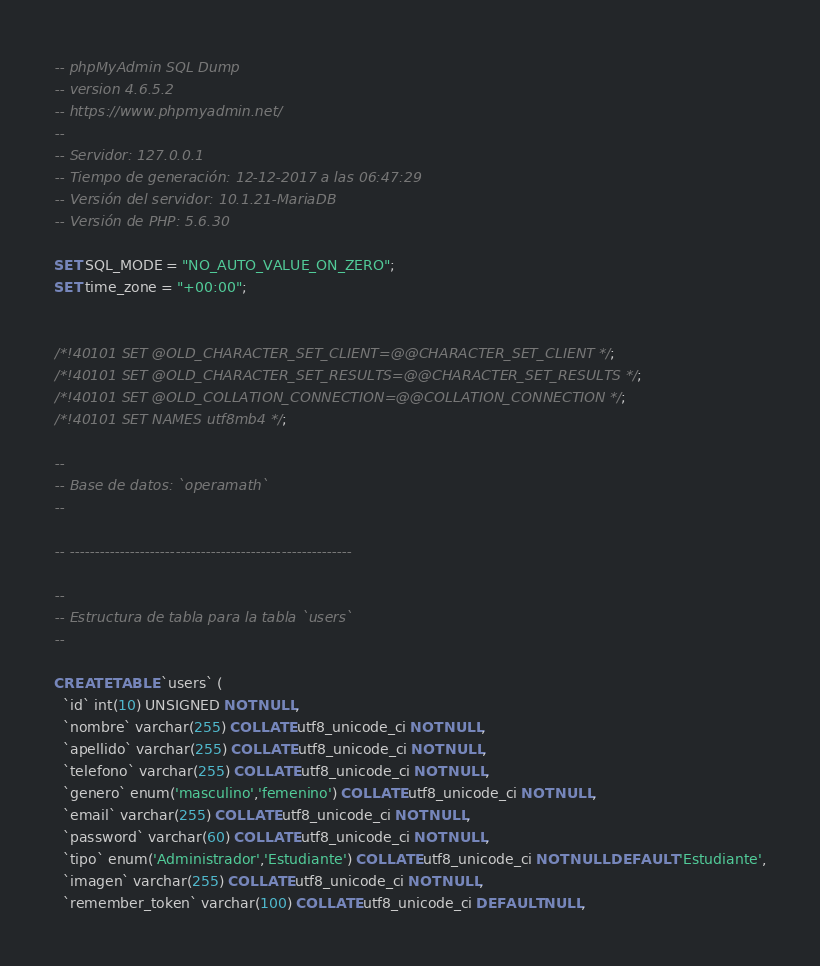Convert code to text. <code><loc_0><loc_0><loc_500><loc_500><_SQL_>-- phpMyAdmin SQL Dump
-- version 4.6.5.2
-- https://www.phpmyadmin.net/
--
-- Servidor: 127.0.0.1
-- Tiempo de generación: 12-12-2017 a las 06:47:29
-- Versión del servidor: 10.1.21-MariaDB
-- Versión de PHP: 5.6.30

SET SQL_MODE = "NO_AUTO_VALUE_ON_ZERO";
SET time_zone = "+00:00";


/*!40101 SET @OLD_CHARACTER_SET_CLIENT=@@CHARACTER_SET_CLIENT */;
/*!40101 SET @OLD_CHARACTER_SET_RESULTS=@@CHARACTER_SET_RESULTS */;
/*!40101 SET @OLD_COLLATION_CONNECTION=@@COLLATION_CONNECTION */;
/*!40101 SET NAMES utf8mb4 */;

--
-- Base de datos: `operamath`
--

-- --------------------------------------------------------

--
-- Estructura de tabla para la tabla `users`
--

CREATE TABLE `users` (
  `id` int(10) UNSIGNED NOT NULL,
  `nombre` varchar(255) COLLATE utf8_unicode_ci NOT NULL,
  `apellido` varchar(255) COLLATE utf8_unicode_ci NOT NULL,
  `telefono` varchar(255) COLLATE utf8_unicode_ci NOT NULL,
  `genero` enum('masculino','femenino') COLLATE utf8_unicode_ci NOT NULL,
  `email` varchar(255) COLLATE utf8_unicode_ci NOT NULL,
  `password` varchar(60) COLLATE utf8_unicode_ci NOT NULL,
  `tipo` enum('Administrador','Estudiante') COLLATE utf8_unicode_ci NOT NULL DEFAULT 'Estudiante',
  `imagen` varchar(255) COLLATE utf8_unicode_ci NOT NULL,
  `remember_token` varchar(100) COLLATE utf8_unicode_ci DEFAULT NULL,</code> 